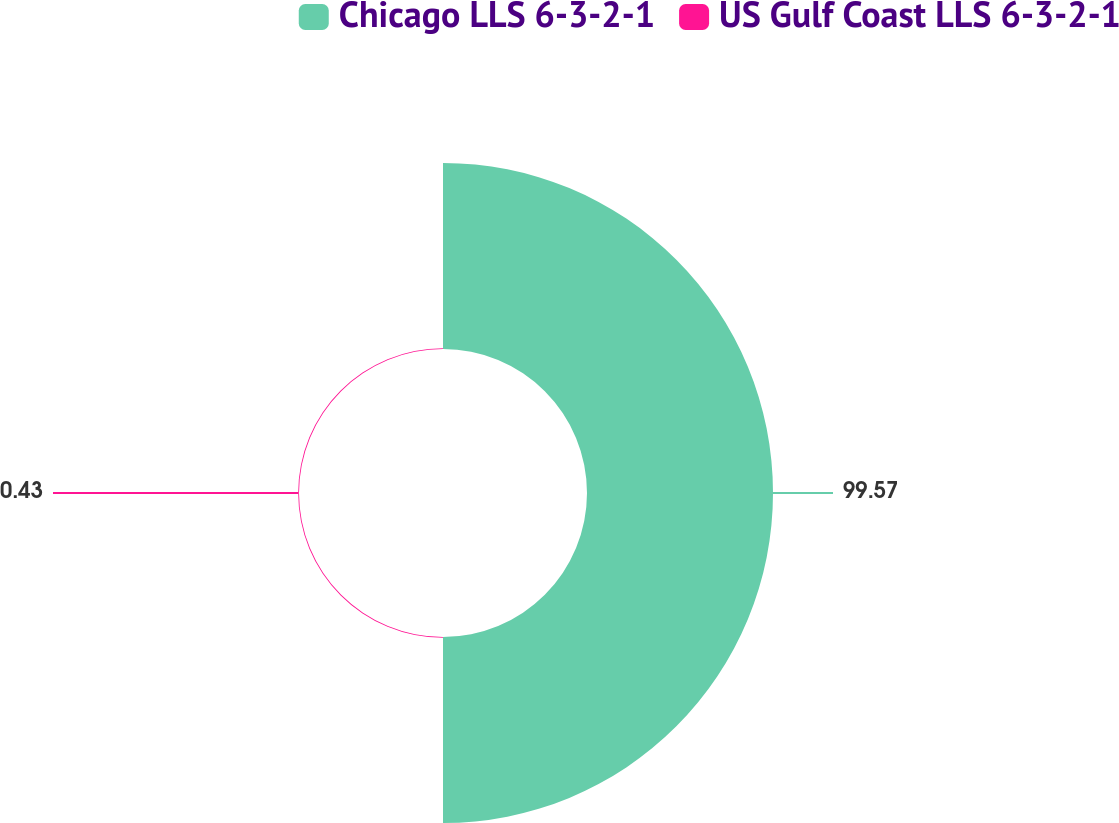Convert chart to OTSL. <chart><loc_0><loc_0><loc_500><loc_500><pie_chart><fcel>Chicago LLS 6-3-2-1<fcel>US Gulf Coast LLS 6-3-2-1<nl><fcel>99.57%<fcel>0.43%<nl></chart> 